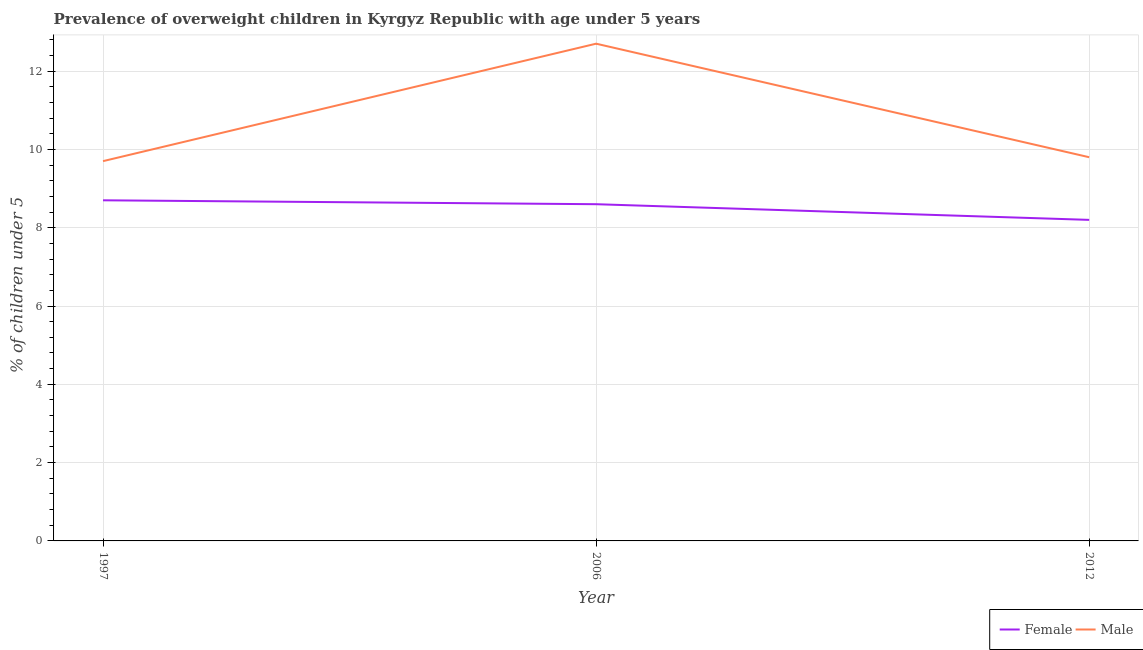Does the line corresponding to percentage of obese male children intersect with the line corresponding to percentage of obese female children?
Keep it short and to the point. No. Is the number of lines equal to the number of legend labels?
Offer a very short reply. Yes. What is the percentage of obese male children in 1997?
Make the answer very short. 9.7. Across all years, what is the maximum percentage of obese male children?
Offer a terse response. 12.7. Across all years, what is the minimum percentage of obese female children?
Keep it short and to the point. 8.2. In which year was the percentage of obese male children maximum?
Provide a succinct answer. 2006. What is the total percentage of obese female children in the graph?
Keep it short and to the point. 25.5. What is the difference between the percentage of obese female children in 1997 and that in 2006?
Give a very brief answer. 0.1. What is the difference between the percentage of obese male children in 2012 and the percentage of obese female children in 2006?
Your response must be concise. 1.2. What is the average percentage of obese female children per year?
Your answer should be very brief. 8.5. In the year 2012, what is the difference between the percentage of obese male children and percentage of obese female children?
Your answer should be very brief. 1.6. What is the ratio of the percentage of obese male children in 1997 to that in 2012?
Your response must be concise. 0.99. Is the percentage of obese male children in 2006 less than that in 2012?
Provide a succinct answer. No. What is the difference between the highest and the second highest percentage of obese female children?
Offer a terse response. 0.1. In how many years, is the percentage of obese female children greater than the average percentage of obese female children taken over all years?
Offer a very short reply. 2. How many lines are there?
Your answer should be very brief. 2. How many years are there in the graph?
Your answer should be compact. 3. What is the difference between two consecutive major ticks on the Y-axis?
Your answer should be very brief. 2. Does the graph contain any zero values?
Make the answer very short. No. Does the graph contain grids?
Ensure brevity in your answer.  Yes. Where does the legend appear in the graph?
Give a very brief answer. Bottom right. How many legend labels are there?
Give a very brief answer. 2. What is the title of the graph?
Make the answer very short. Prevalence of overweight children in Kyrgyz Republic with age under 5 years. Does "Mineral" appear as one of the legend labels in the graph?
Your answer should be very brief. No. What is the label or title of the Y-axis?
Your answer should be compact.  % of children under 5. What is the  % of children under 5 of Female in 1997?
Offer a very short reply. 8.7. What is the  % of children under 5 in Male in 1997?
Your response must be concise. 9.7. What is the  % of children under 5 in Female in 2006?
Your answer should be compact. 8.6. What is the  % of children under 5 in Male in 2006?
Ensure brevity in your answer.  12.7. What is the  % of children under 5 of Female in 2012?
Keep it short and to the point. 8.2. What is the  % of children under 5 of Male in 2012?
Offer a very short reply. 9.8. Across all years, what is the maximum  % of children under 5 in Female?
Your answer should be compact. 8.7. Across all years, what is the maximum  % of children under 5 in Male?
Keep it short and to the point. 12.7. Across all years, what is the minimum  % of children under 5 of Female?
Give a very brief answer. 8.2. Across all years, what is the minimum  % of children under 5 of Male?
Provide a short and direct response. 9.7. What is the total  % of children under 5 in Male in the graph?
Offer a very short reply. 32.2. What is the difference between the  % of children under 5 of Female in 1997 and that in 2006?
Make the answer very short. 0.1. What is the difference between the  % of children under 5 in Male in 1997 and that in 2012?
Offer a very short reply. -0.1. What is the difference between the  % of children under 5 in Female in 2006 and that in 2012?
Provide a short and direct response. 0.4. What is the difference between the  % of children under 5 in Male in 2006 and that in 2012?
Ensure brevity in your answer.  2.9. What is the difference between the  % of children under 5 in Female in 1997 and the  % of children under 5 in Male in 2006?
Make the answer very short. -4. What is the difference between the  % of children under 5 in Female in 2006 and the  % of children under 5 in Male in 2012?
Offer a very short reply. -1.2. What is the average  % of children under 5 of Male per year?
Your response must be concise. 10.73. In the year 2006, what is the difference between the  % of children under 5 of Female and  % of children under 5 of Male?
Make the answer very short. -4.1. In the year 2012, what is the difference between the  % of children under 5 of Female and  % of children under 5 of Male?
Offer a very short reply. -1.6. What is the ratio of the  % of children under 5 in Female in 1997 to that in 2006?
Provide a short and direct response. 1.01. What is the ratio of the  % of children under 5 in Male in 1997 to that in 2006?
Make the answer very short. 0.76. What is the ratio of the  % of children under 5 in Female in 1997 to that in 2012?
Make the answer very short. 1.06. What is the ratio of the  % of children under 5 in Female in 2006 to that in 2012?
Offer a terse response. 1.05. What is the ratio of the  % of children under 5 in Male in 2006 to that in 2012?
Provide a succinct answer. 1.3. What is the difference between the highest and the second highest  % of children under 5 in Female?
Your answer should be very brief. 0.1. What is the difference between the highest and the second highest  % of children under 5 in Male?
Your answer should be compact. 2.9. 